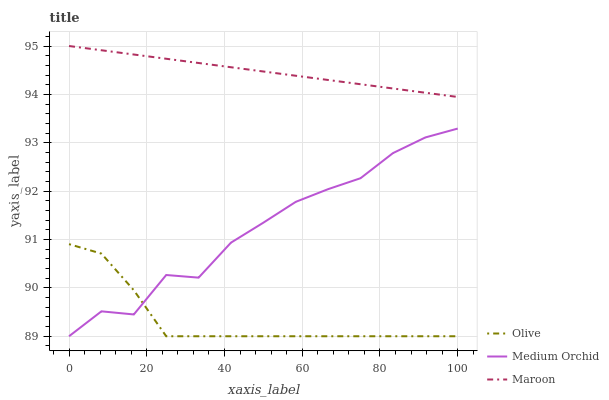Does Medium Orchid have the minimum area under the curve?
Answer yes or no. No. Does Medium Orchid have the maximum area under the curve?
Answer yes or no. No. Is Medium Orchid the smoothest?
Answer yes or no. No. Is Maroon the roughest?
Answer yes or no. No. Does Maroon have the lowest value?
Answer yes or no. No. Does Medium Orchid have the highest value?
Answer yes or no. No. Is Medium Orchid less than Maroon?
Answer yes or no. Yes. Is Maroon greater than Olive?
Answer yes or no. Yes. Does Medium Orchid intersect Maroon?
Answer yes or no. No. 